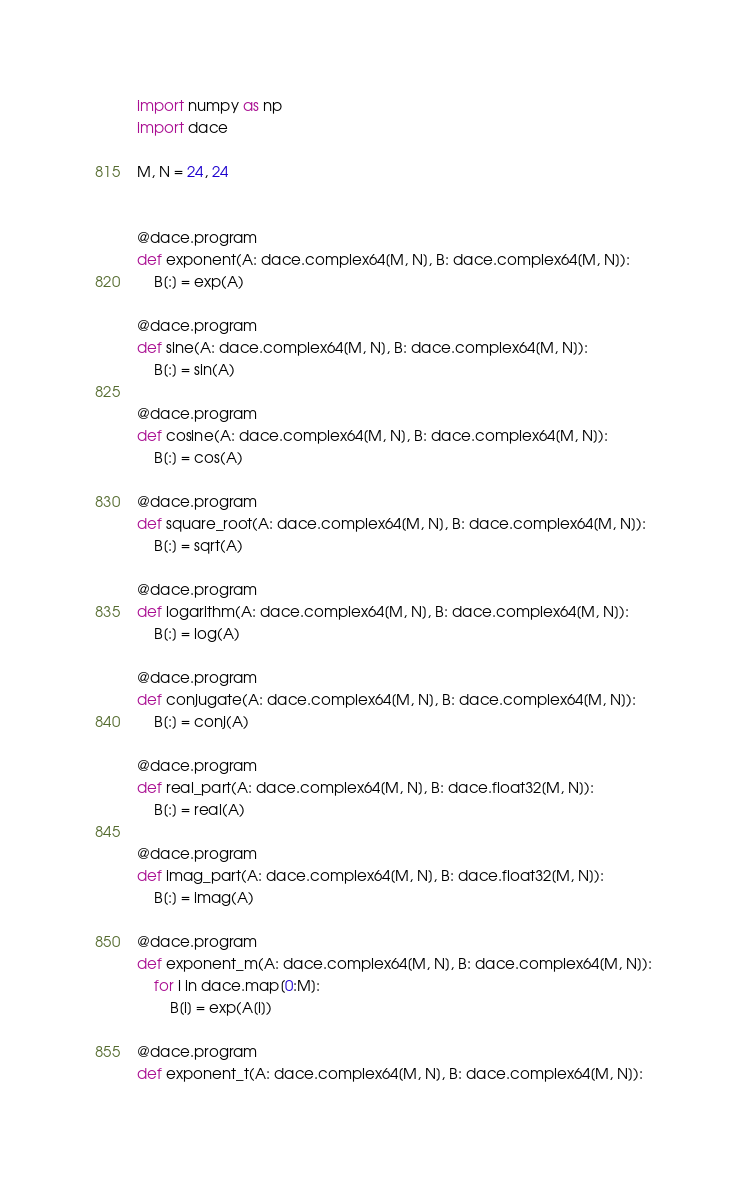Convert code to text. <code><loc_0><loc_0><loc_500><loc_500><_Python_>import numpy as np
import dace

M, N = 24, 24


@dace.program
def exponent(A: dace.complex64[M, N], B: dace.complex64[M, N]):
    B[:] = exp(A)

@dace.program
def sine(A: dace.complex64[M, N], B: dace.complex64[M, N]):
    B[:] = sin(A)

@dace.program
def cosine(A: dace.complex64[M, N], B: dace.complex64[M, N]):
    B[:] = cos(A)

@dace.program
def square_root(A: dace.complex64[M, N], B: dace.complex64[M, N]):
    B[:] = sqrt(A)

@dace.program
def logarithm(A: dace.complex64[M, N], B: dace.complex64[M, N]):
    B[:] = log(A)

@dace.program
def conjugate(A: dace.complex64[M, N], B: dace.complex64[M, N]):
    B[:] = conj(A)

@dace.program
def real_part(A: dace.complex64[M, N], B: dace.float32[M, N]):
    B[:] = real(A)

@dace.program
def imag_part(A: dace.complex64[M, N], B: dace.float32[M, N]):
    B[:] = imag(A)

@dace.program
def exponent_m(A: dace.complex64[M, N], B: dace.complex64[M, N]):
    for i in dace.map[0:M]:
        B[i] = exp(A[i])

@dace.program
def exponent_t(A: dace.complex64[M, N], B: dace.complex64[M, N]):</code> 